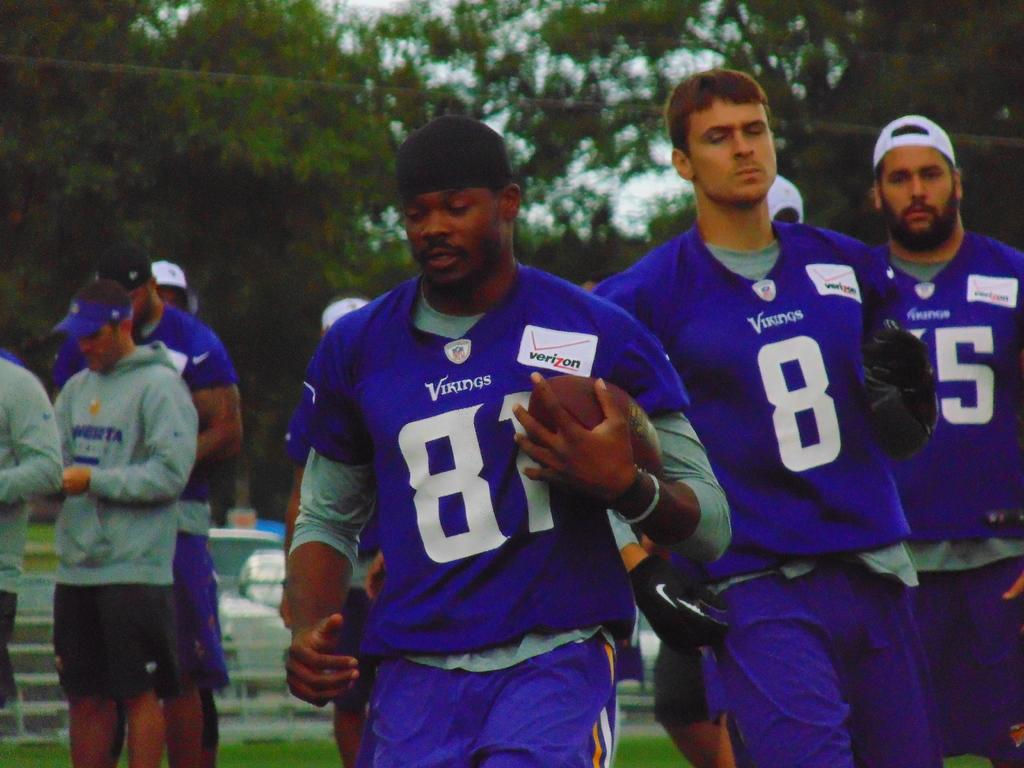How many people are in the image? There are people in the image, but the exact number is not specified. What is the man holding in the image? The man is holding a ball in the image. What type of surface is visible in the image? There is grass visible in the image. What is the wall is present in the image? There is a wall in the image. Can you describe the objects in the image? There are objects in the image, but their specific nature is not mentioned. What can be seen in the background of the image? There are trees and the sky visible in the background of the image. What type of basin is visible in the image? There is no basin present in the image. What is the purpose of the journey depicted in the image? There is no journey depicted in the image. 